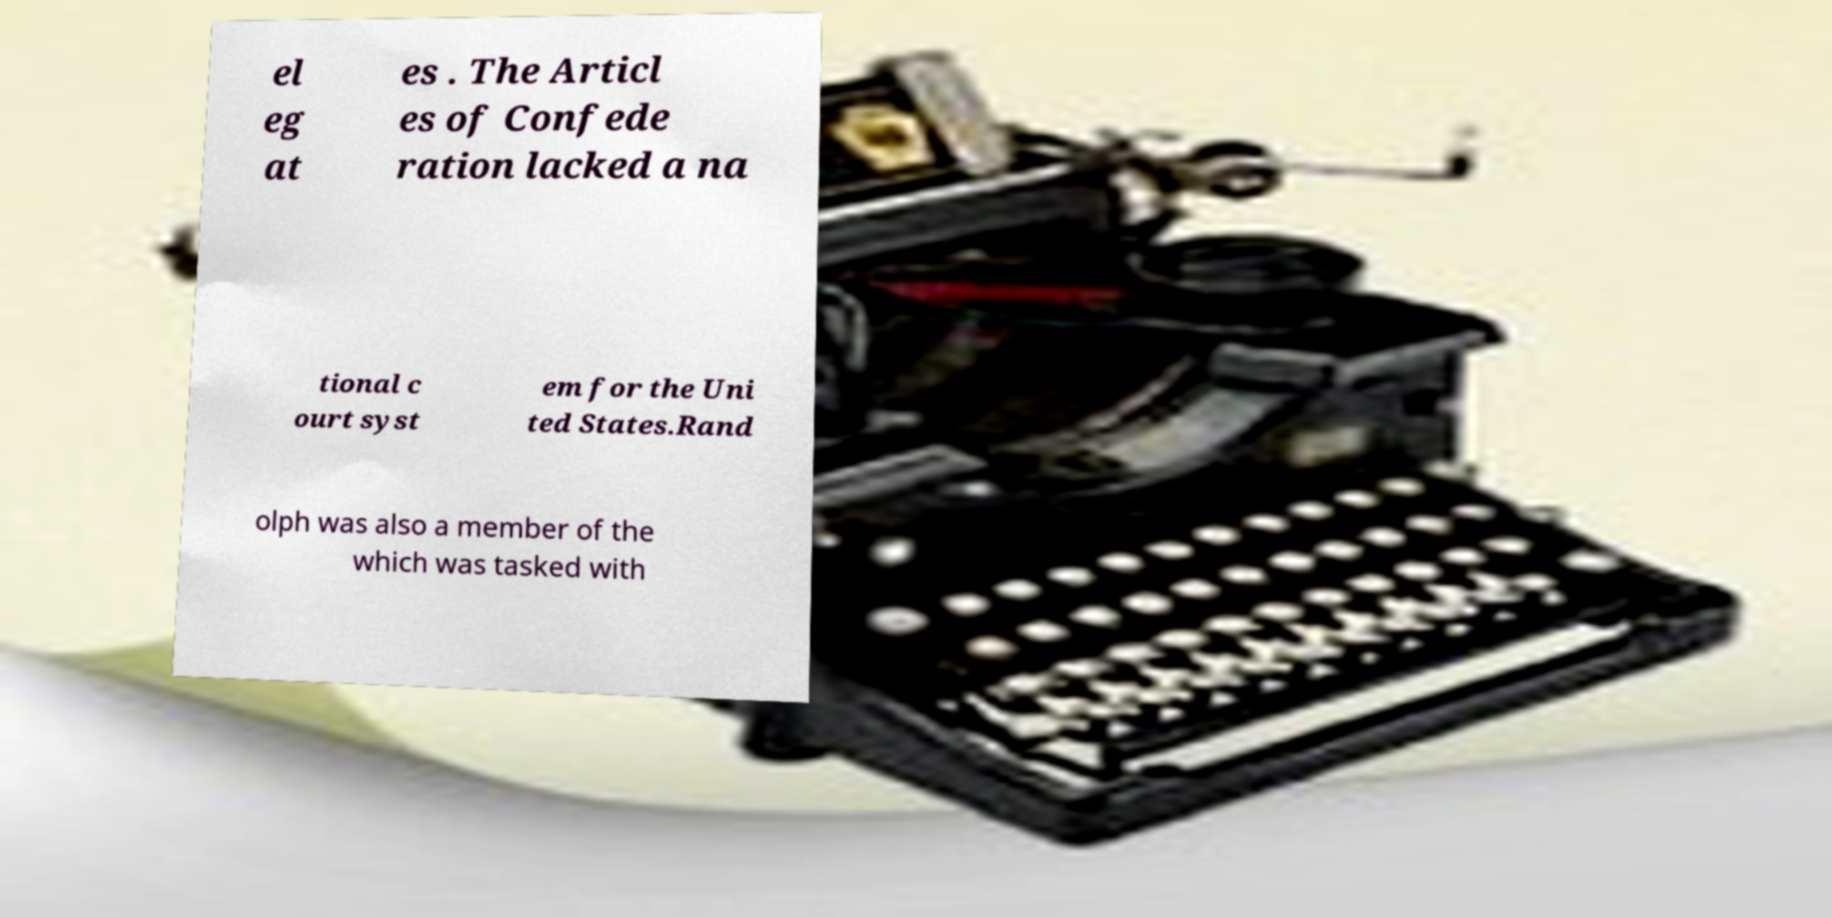Please identify and transcribe the text found in this image. el eg at es . The Articl es of Confede ration lacked a na tional c ourt syst em for the Uni ted States.Rand olph was also a member of the which was tasked with 